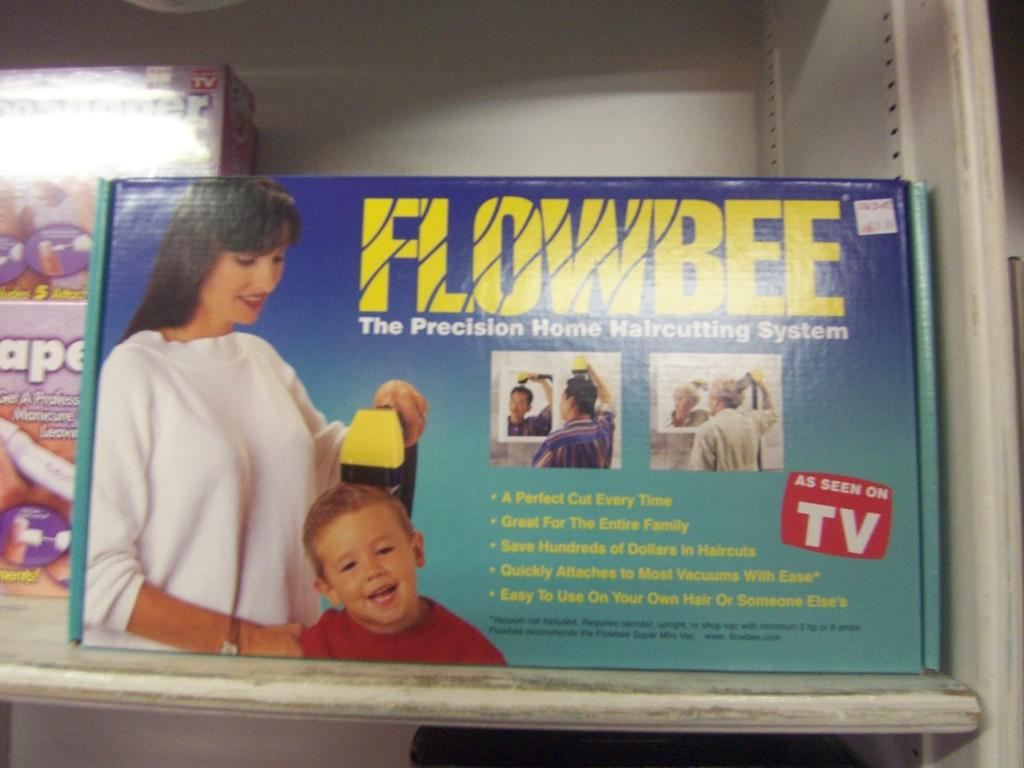What objects are visible in the image? There are boxes in the image. Where are the boxes located? The boxes are placed on a shelf. What type of match is being played in the image? There is no match being played in the image; it only features boxes placed on a shelf. 